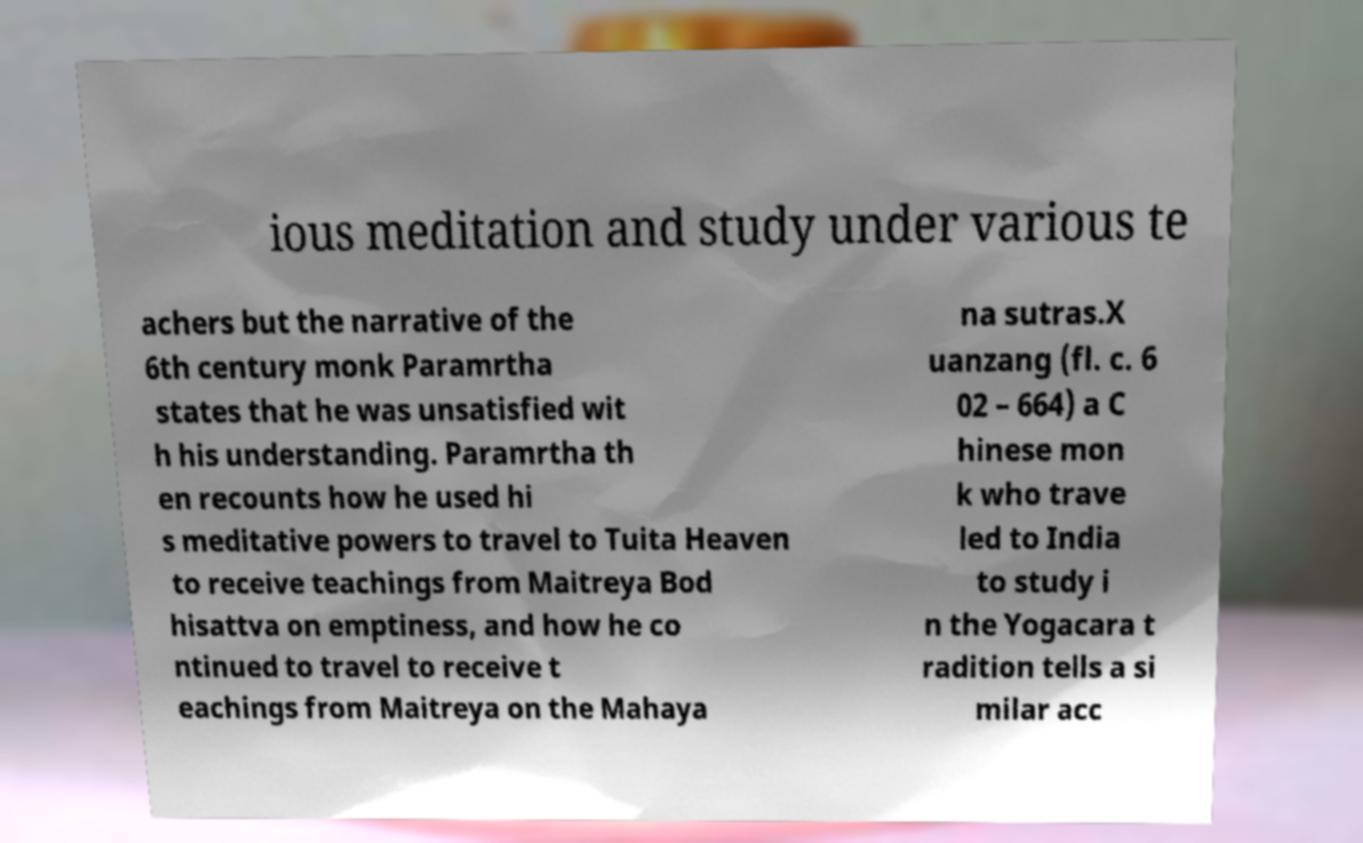Could you extract and type out the text from this image? ious meditation and study under various te achers but the narrative of the 6th century monk Paramrtha states that he was unsatisfied wit h his understanding. Paramrtha th en recounts how he used hi s meditative powers to travel to Tuita Heaven to receive teachings from Maitreya Bod hisattva on emptiness, and how he co ntinued to travel to receive t eachings from Maitreya on the Mahaya na sutras.X uanzang (fl. c. 6 02 – 664) a C hinese mon k who trave led to India to study i n the Yogacara t radition tells a si milar acc 